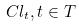<formula> <loc_0><loc_0><loc_500><loc_500>C l _ { t } , t \in T</formula> 